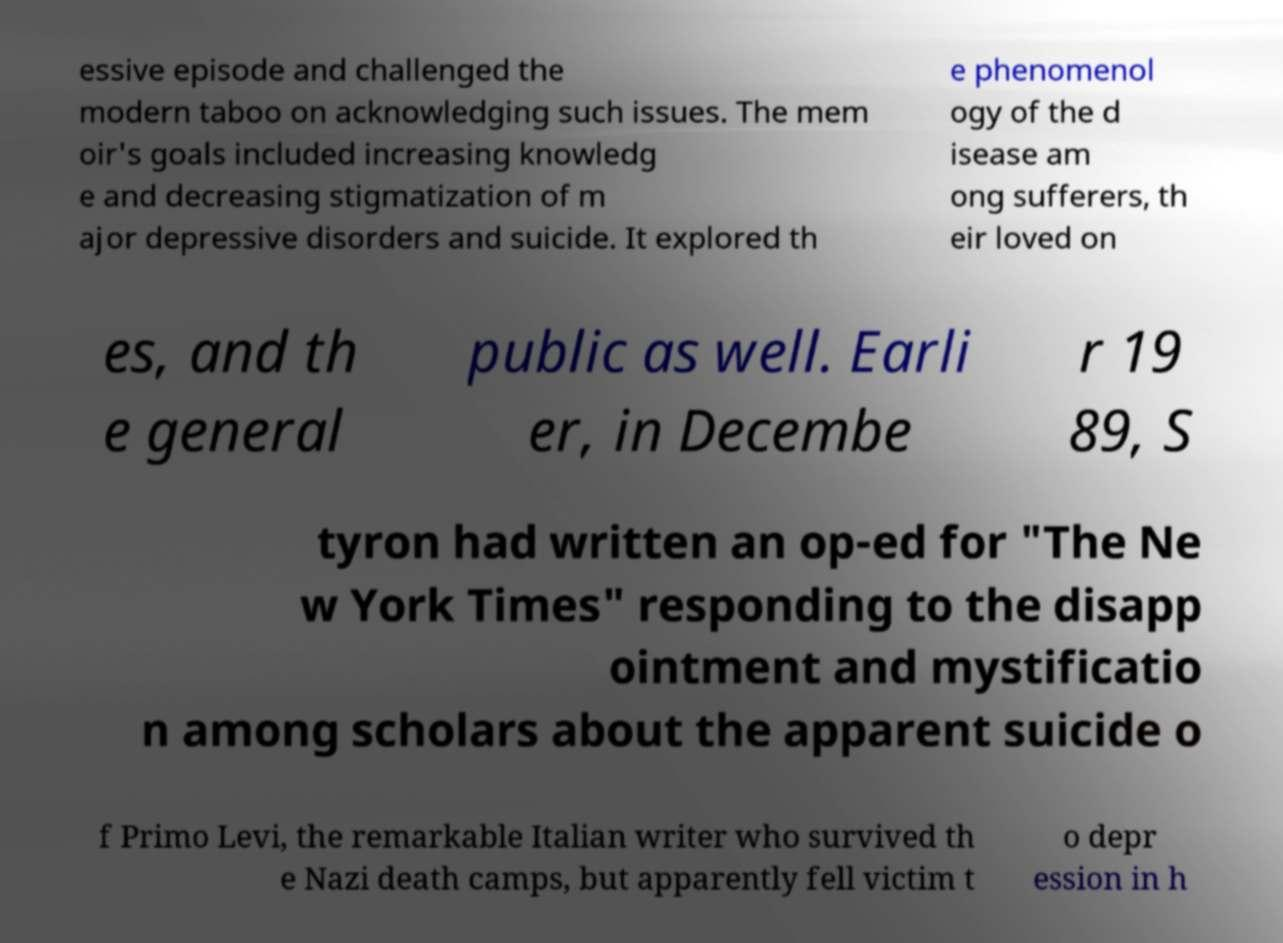What messages or text are displayed in this image? I need them in a readable, typed format. essive episode and challenged the modern taboo on acknowledging such issues. The mem oir's goals included increasing knowledg e and decreasing stigmatization of m ajor depressive disorders and suicide. It explored th e phenomenol ogy of the d isease am ong sufferers, th eir loved on es, and th e general public as well. Earli er, in Decembe r 19 89, S tyron had written an op-ed for "The Ne w York Times" responding to the disapp ointment and mystificatio n among scholars about the apparent suicide o f Primo Levi, the remarkable Italian writer who survived th e Nazi death camps, but apparently fell victim t o depr ession in h 